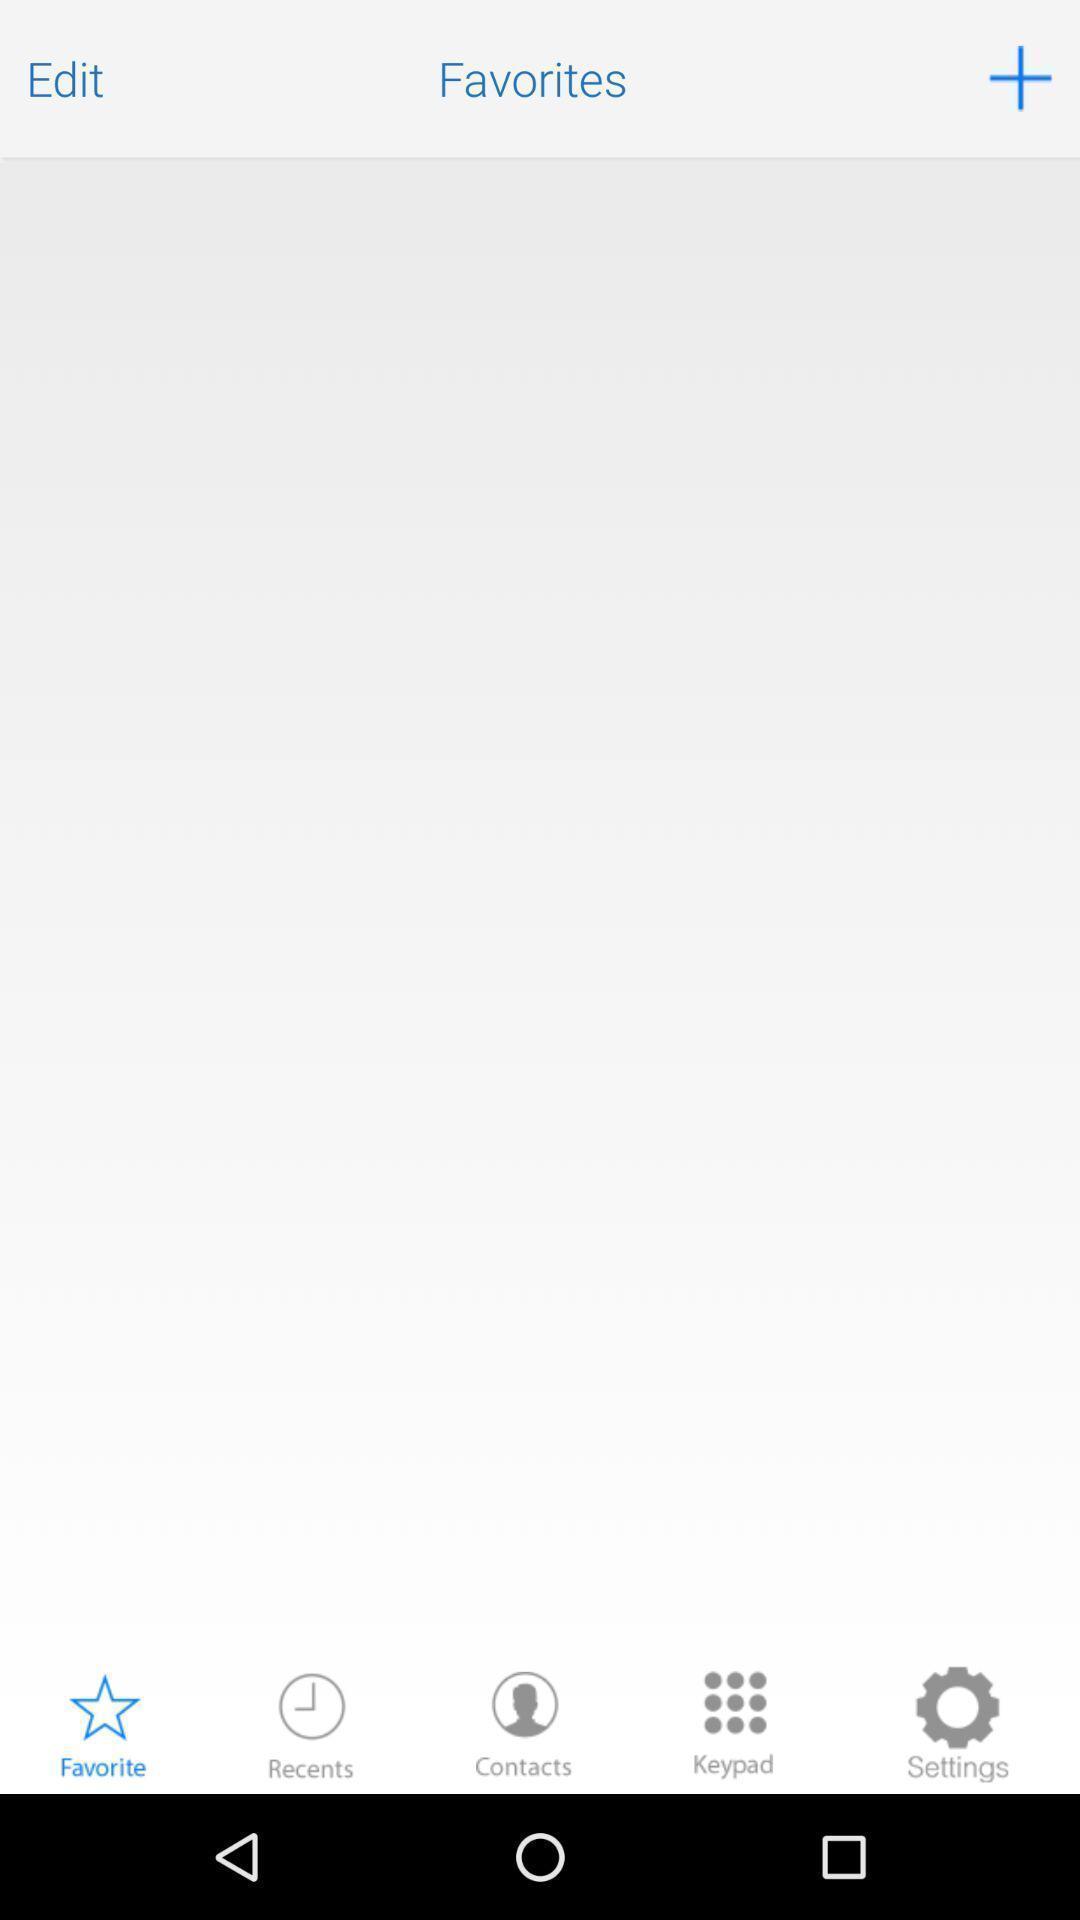What details can you identify in this image? Screen showing the blank page in favorites tab. 